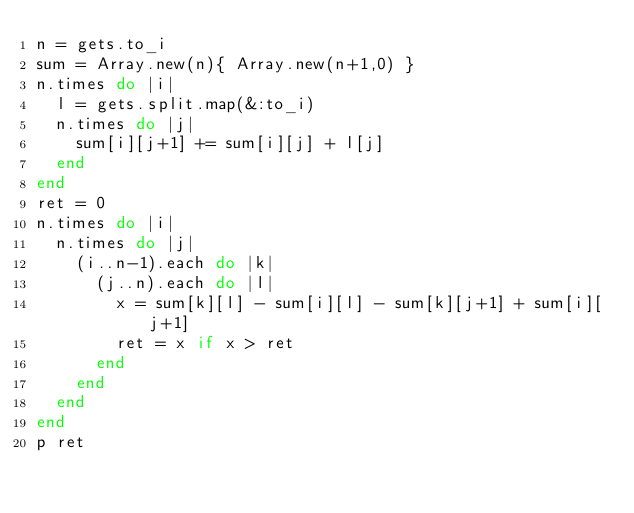<code> <loc_0><loc_0><loc_500><loc_500><_Ruby_>n = gets.to_i
sum = Array.new(n){ Array.new(n+1,0) }
n.times do |i|
  l = gets.split.map(&:to_i)
  n.times do |j|
    sum[i][j+1] += sum[i][j] + l[j]
  end
end
ret = 0
n.times do |i|
  n.times do |j|
    (i..n-1).each do |k|
      (j..n).each do |l|
        x = sum[k][l] - sum[i][l] - sum[k][j+1] + sum[i][j+1]
        ret = x if x > ret
      end
    end
  end
end
p ret</code> 